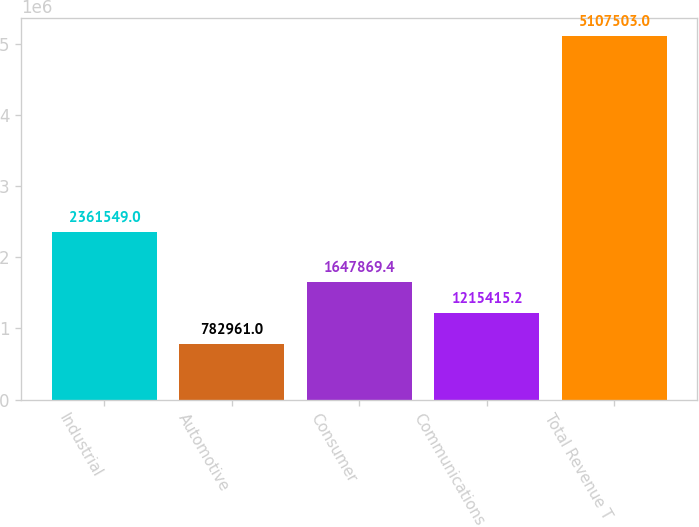Convert chart to OTSL. <chart><loc_0><loc_0><loc_500><loc_500><bar_chart><fcel>Industrial<fcel>Automotive<fcel>Consumer<fcel>Communications<fcel>Total Revenue T<nl><fcel>2.36155e+06<fcel>782961<fcel>1.64787e+06<fcel>1.21542e+06<fcel>5.1075e+06<nl></chart> 